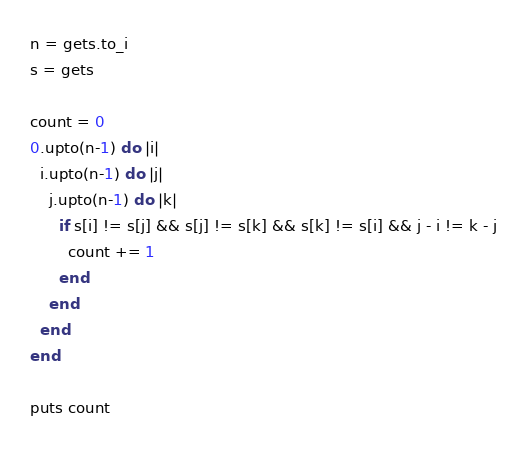<code> <loc_0><loc_0><loc_500><loc_500><_Ruby_>n = gets.to_i
s = gets

count = 0
0.upto(n-1) do |i|
  i.upto(n-1) do |j|
    j.upto(n-1) do |k|
      if s[i] != s[j] && s[j] != s[k] && s[k] != s[i] && j - i != k - j
        count += 1
      end
    end
  end
end

puts count</code> 